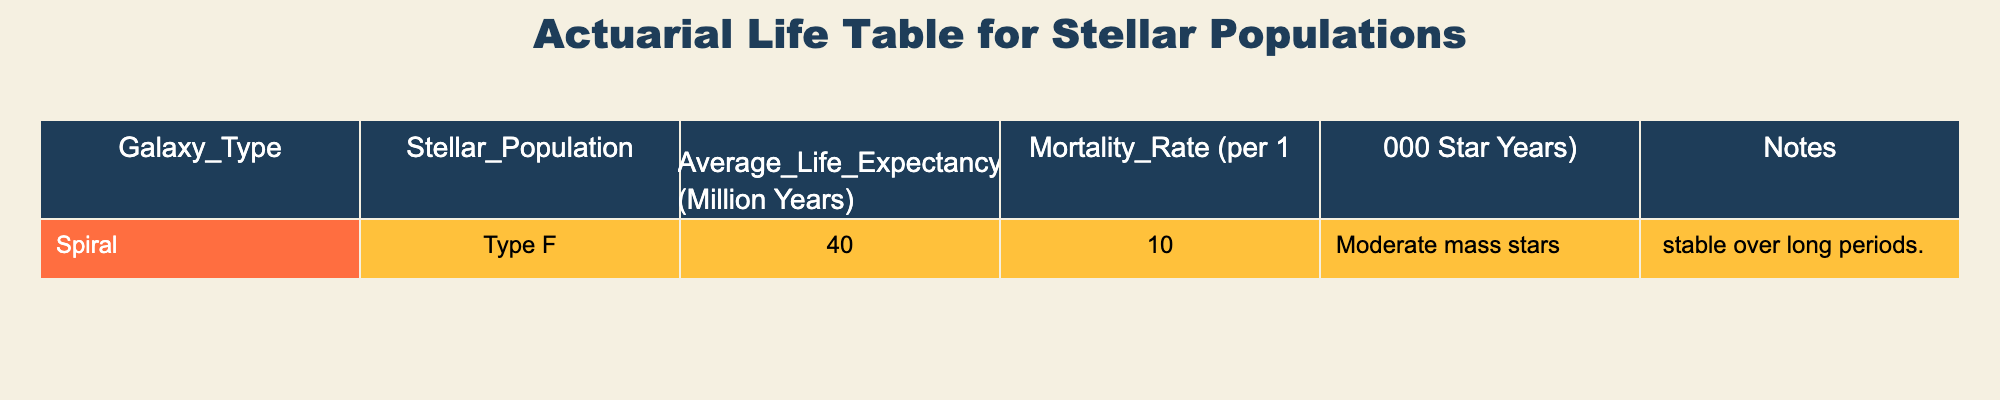What is the average life expectancy of Type F stars? The table lists the average life expectancy for Type F stars as 40 million years. Therefore, the answer is directly taken from the "Average Life Expectancy" column corresponding to Type F stars.
Answer: 40 million years What is the mortality rate for Type F stellar populations? The mortality rate for Type F stars is shown in the table as 10 per 1,000 star years. This is a specific value that can be retrieved directly from the "Mortality Rate" column for Type F stars.
Answer: 10 per 1,000 star years Is the average life expectancy of Type F stars higher than 35 million years? From the table, the average life expectancy of Type F stars is 40 million years, which is indeed higher than 35 million years. Thus, the statement is true based on the direct value in the table.
Answer: Yes How much longer can Type F stars be expected to live compared to the mortality rate expressed in years? Here, we are asked to compare the average life expectancy of Type F stars (40 million years) directly to a mortality concept. Since mortality rate represents deaths per 1,000 star years rather than a direct lifespan value, no direct comparison can be made in years. This requires recognizing the difference between the two metrics.
Answer: Not applicable If we combine the average life expectancy of Type F stars with a hypothetical average life expectancy of Type G stars (let's assume 30 million years for this exercise), what is the total combined life expectancy of Type F and Type G stars? To calculate the combined life expectancy of Type F and Type G stars, we would add both life expectancies together: 40 million years (Type F) + 30 million years (assumed Type G) = 70 million years. This is a straightforward addition based on hypothetical values.
Answer: 70 million years Is the statement "Type F stars are the shortest-lived among spiral galaxy populations" true based on the data? The table currently only shows data for Type F stars, and without additional rows for other stellar populations in spiral galaxies, we can't verify the claim. Thus, this statement cannot be confirmed with the information available.
Answer: Not enough data What is the significance of the notes provided for Type F stars? The notes states that Type F stars are moderate mass stars that are stable over long periods, meaning they do not face high rates of variation or instability. This directly impacts our understanding of their lifespan and mortality rates, clarifying the context behind their numerical data.
Answer: They are stable moderate mass stars 